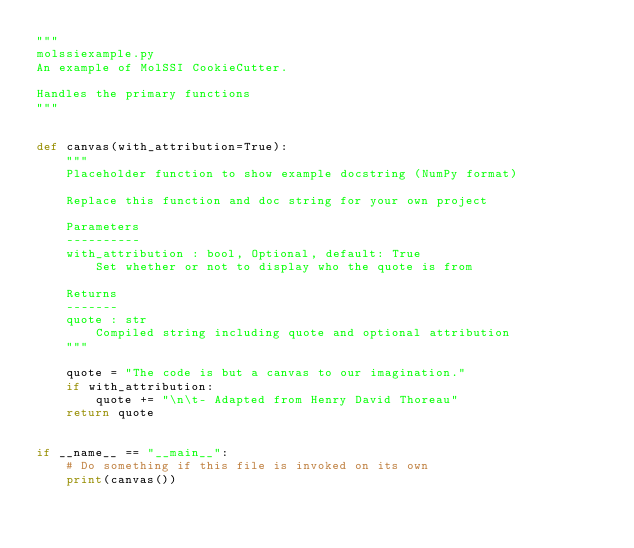<code> <loc_0><loc_0><loc_500><loc_500><_Python_>"""
molssiexample.py
An example of MolSSI CookieCutter.

Handles the primary functions
"""


def canvas(with_attribution=True):
    """
    Placeholder function to show example docstring (NumPy format)

    Replace this function and doc string for your own project

    Parameters
    ----------
    with_attribution : bool, Optional, default: True
        Set whether or not to display who the quote is from

    Returns
    -------
    quote : str
        Compiled string including quote and optional attribution
    """

    quote = "The code is but a canvas to our imagination."
    if with_attribution:
        quote += "\n\t- Adapted from Henry David Thoreau"
    return quote


if __name__ == "__main__":
    # Do something if this file is invoked on its own
    print(canvas())
</code> 